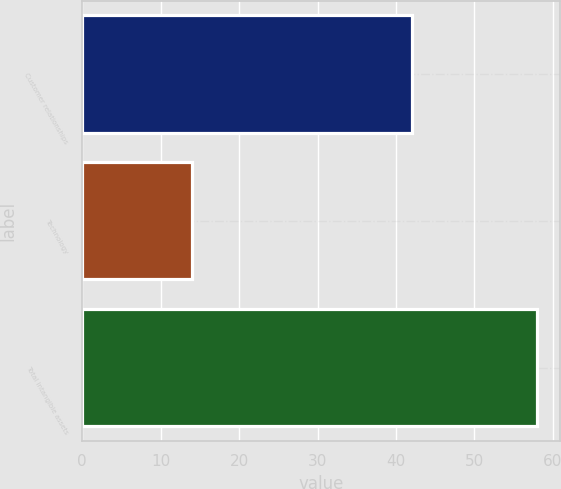Convert chart to OTSL. <chart><loc_0><loc_0><loc_500><loc_500><bar_chart><fcel>Customer relationships<fcel>Technology<fcel>Total intangible assets<nl><fcel>42<fcel>14<fcel>58<nl></chart> 